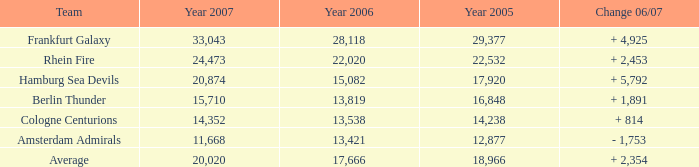What is the aggregate of year 2007(s), when the year 2005 is more than 29,377? None. 